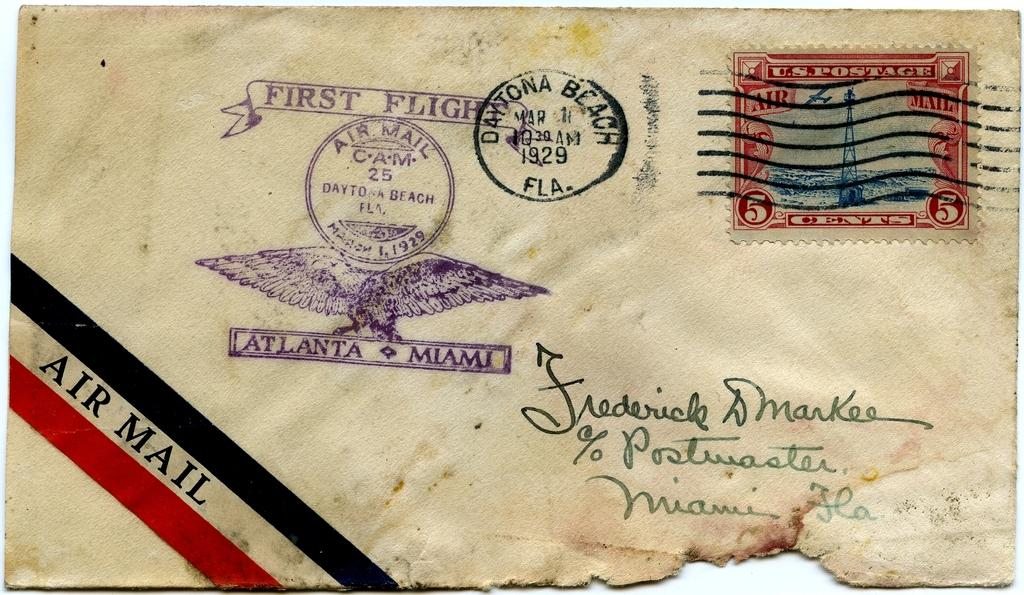<image>
Provide a brief description of the given image. Air Mail first flight from Atlanta to Miami is stamped on this envelope. 